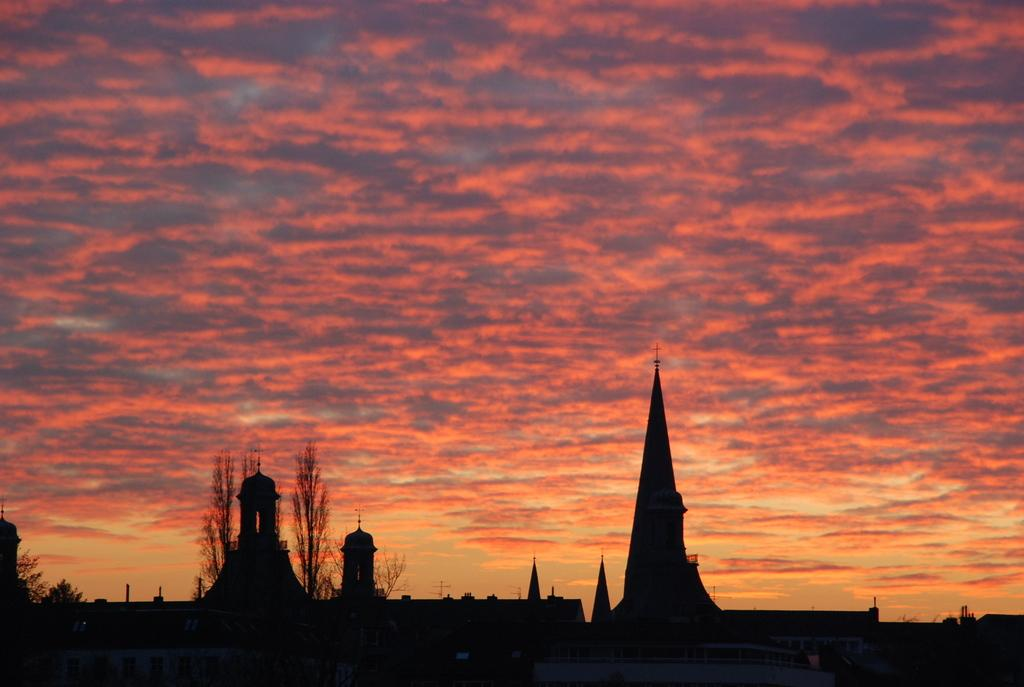What is located at the bottom of the image? There are buildings and trees at the bottom of the image. What can be seen in the sky at the top of the image? The sky is visible at the top of the image, and clouds are present in it. How many ants can be seen exchanging goods at the bottom of the image? There are no ants present in the image, and they are not exchanging goods. What is the amount of rainfall depicted in the image? The image does not depict any rainfall, so it is not possible to determine the amount. 